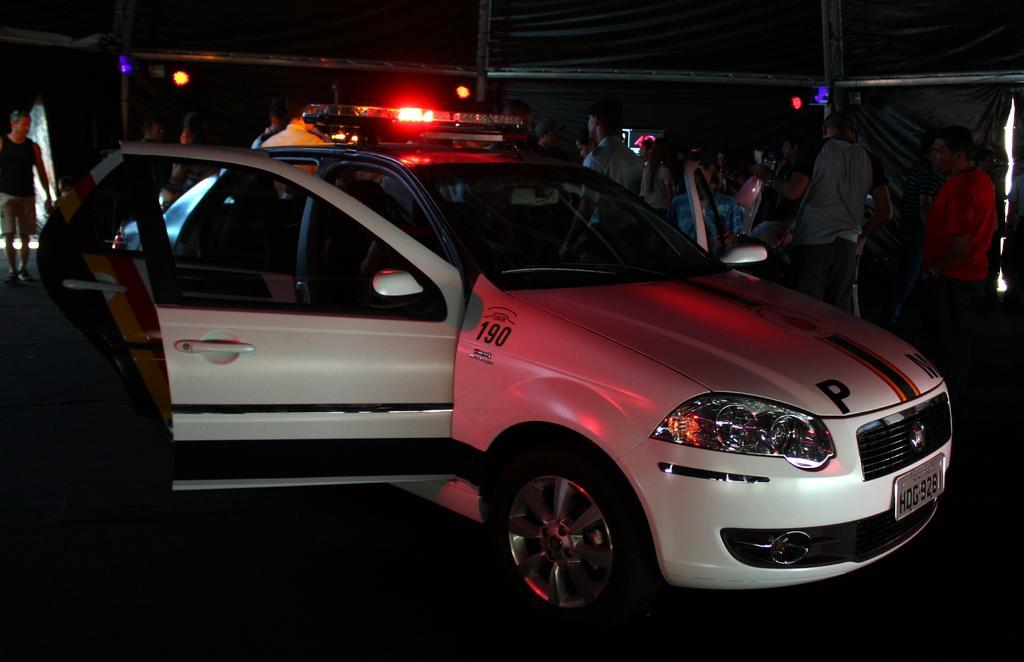In one or two sentences, can you explain what this image depicts? In this picture I can see a car and lights on it. In the background I can see group of people are standing. The background of the image is dark. The car is white in color. 